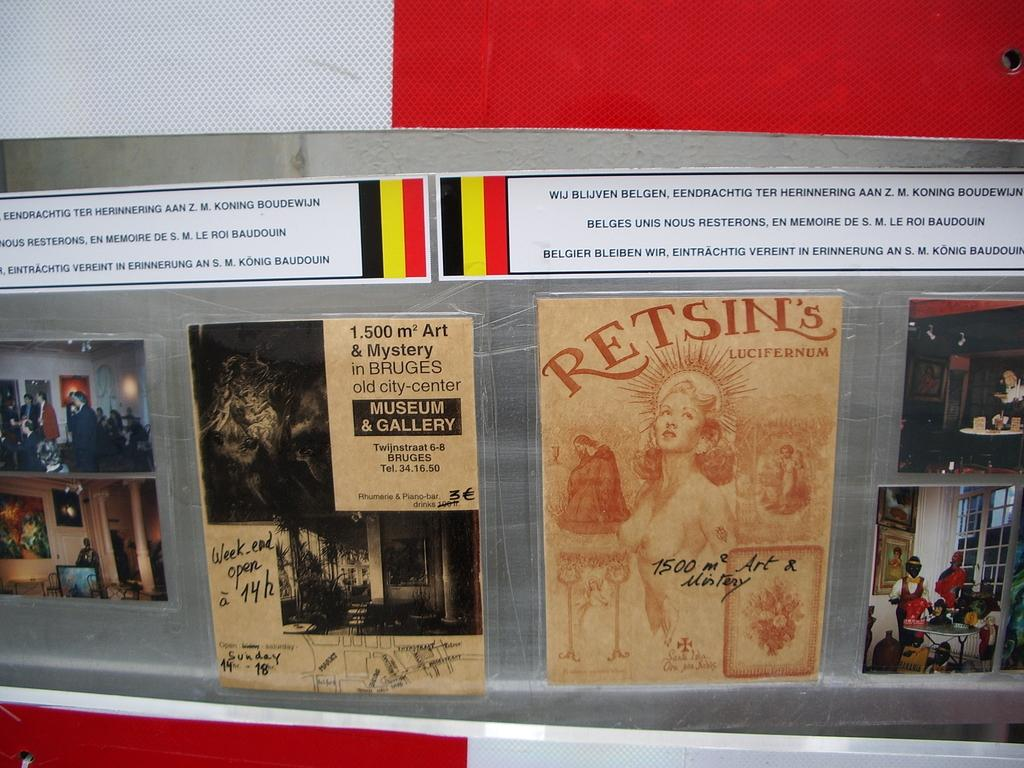Provide a one-sentence caption for the provided image. Display of several posters in another language with one reading Retsins. 